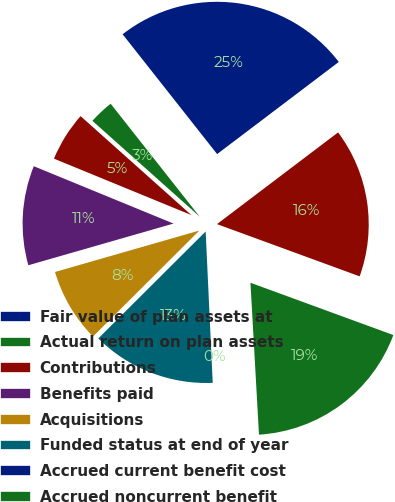Convert chart. <chart><loc_0><loc_0><loc_500><loc_500><pie_chart><fcel>Fair value of plan assets at<fcel>Actual return on plan assets<fcel>Contributions<fcel>Benefits paid<fcel>Acquisitions<fcel>Funded status at end of year<fcel>Accrued current benefit cost<fcel>Accrued noncurrent benefit<fcel>Total<nl><fcel>25.31%<fcel>2.77%<fcel>5.4%<fcel>10.65%<fcel>8.02%<fcel>13.27%<fcel>0.15%<fcel>18.52%<fcel>15.9%<nl></chart> 